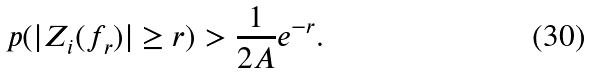Convert formula to latex. <formula><loc_0><loc_0><loc_500><loc_500>\ p ( | Z _ { i } ( f _ { r } ) | \geq r ) > \frac { 1 } { 2 A } e ^ { - r } .</formula> 